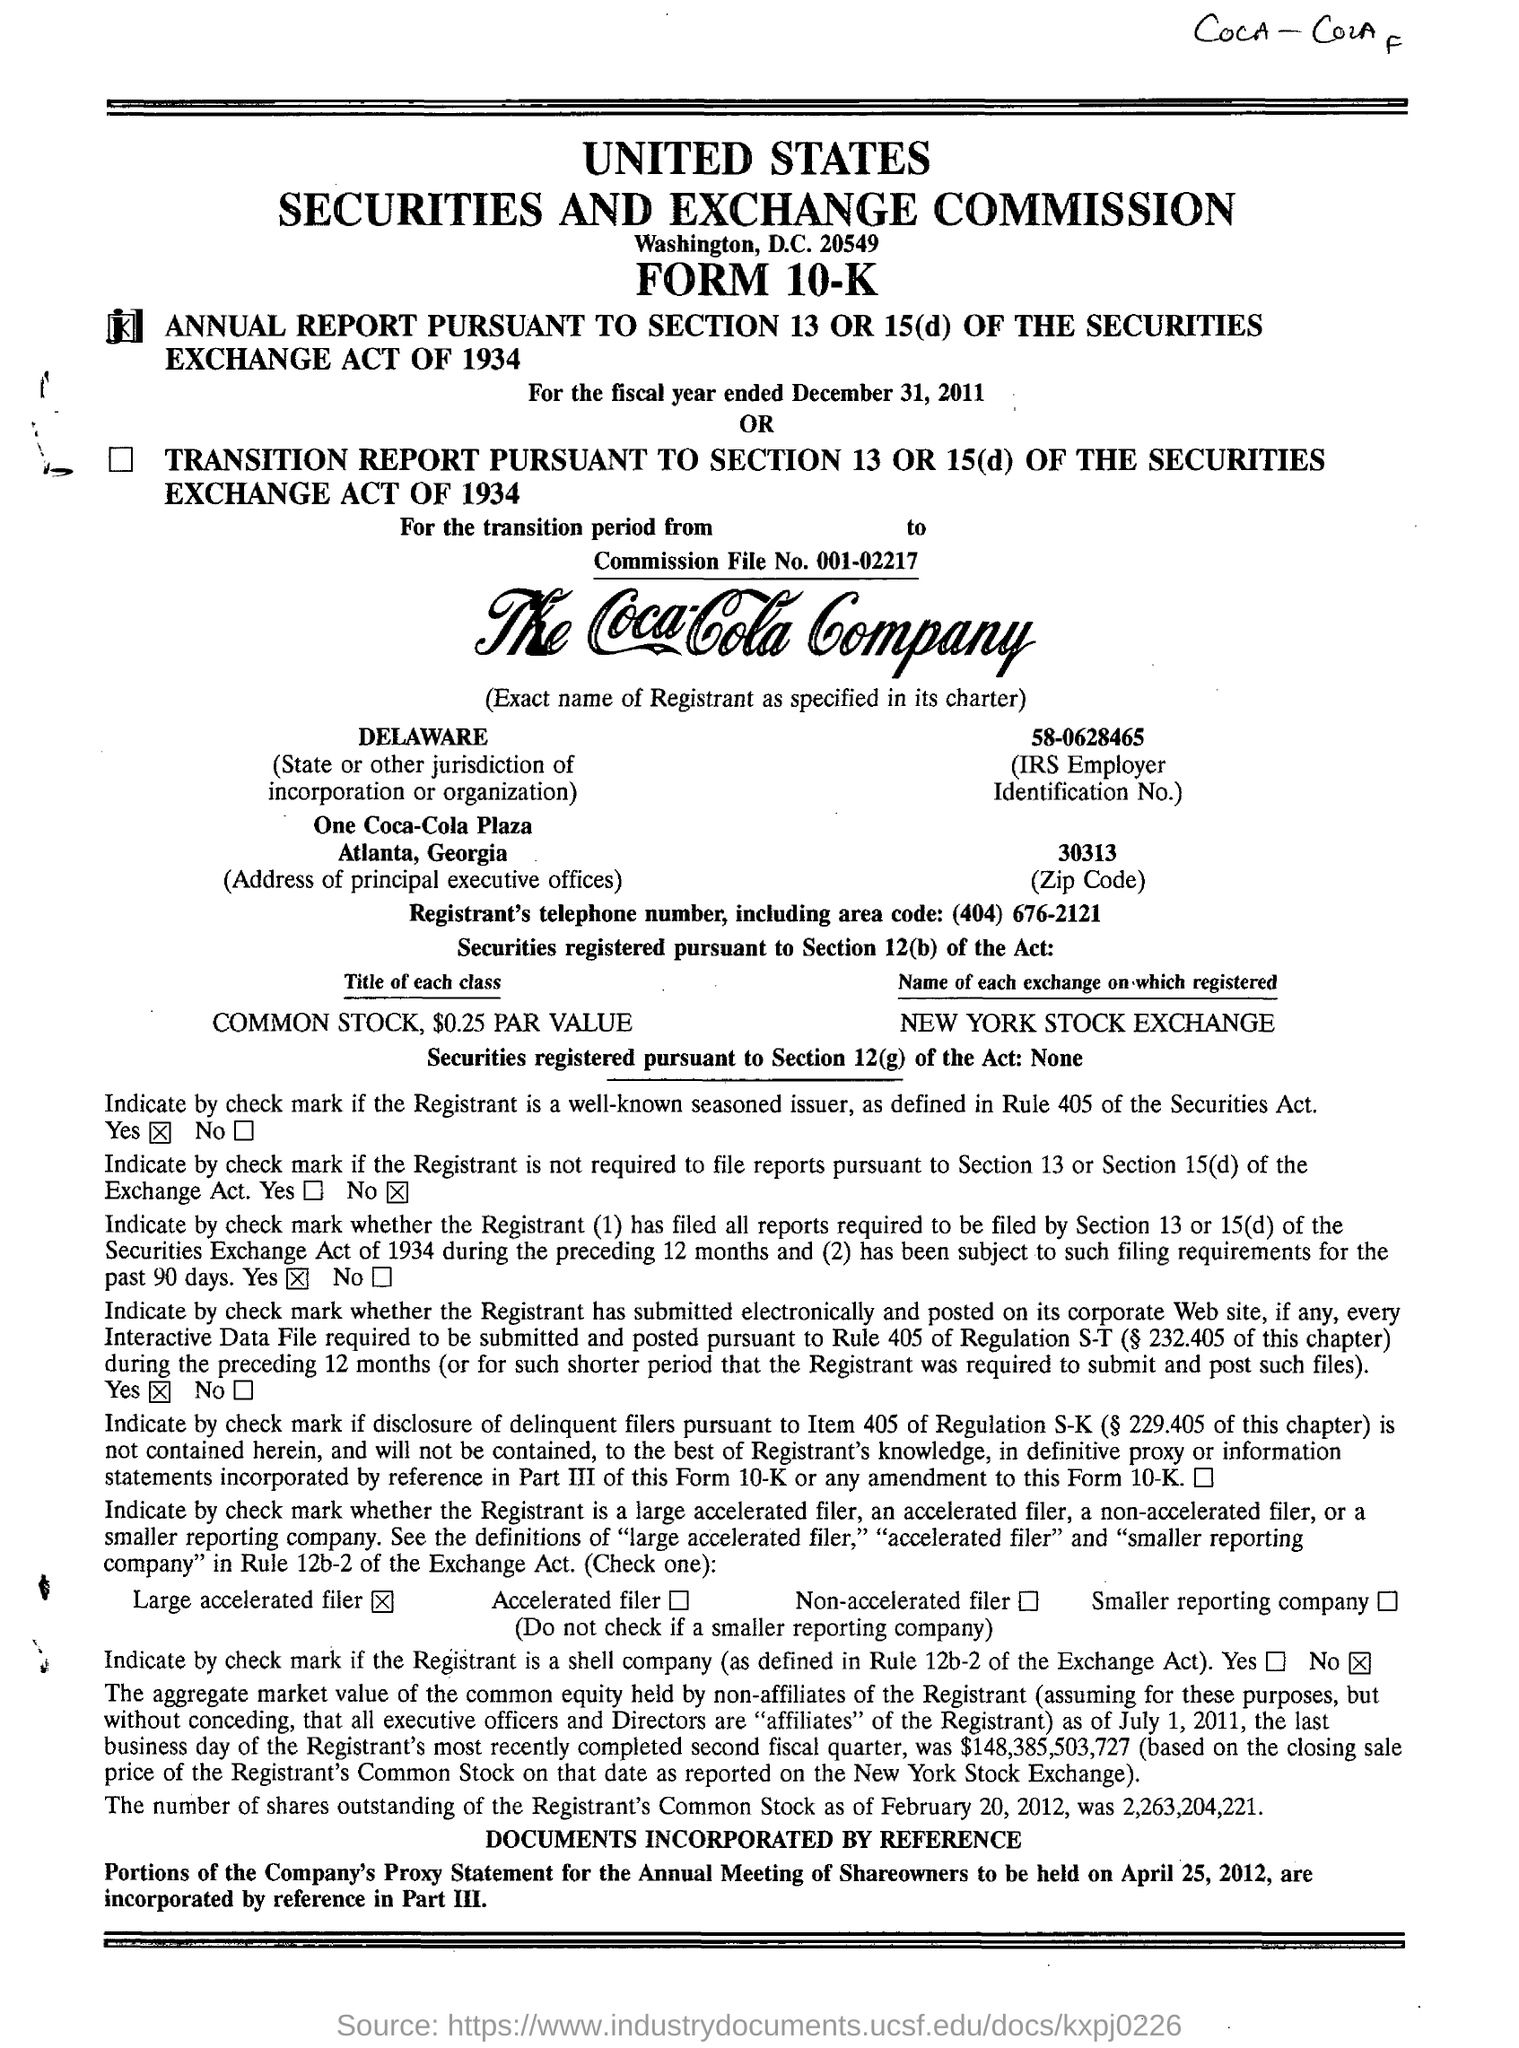List a handful of essential elements in this visual. One Coca-Cola Plaza is located in Atlanta, Georgia. What is the Commission File Number? The Commission File Number is 001-02217. The United States Securities and Exchange Commission is from Washington, D.C. The common stock has a par value of $0.25. 